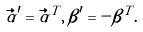Convert formula to latex. <formula><loc_0><loc_0><loc_500><loc_500>\vec { \alpha } ^ { \prime } = \vec { \alpha } ^ { T } , \, \beta ^ { \prime } = - \beta ^ { T } .</formula> 